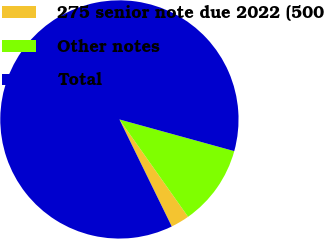Convert chart to OTSL. <chart><loc_0><loc_0><loc_500><loc_500><pie_chart><fcel>275 senior note due 2022 (500<fcel>Other notes<fcel>Total<nl><fcel>2.54%<fcel>10.94%<fcel>86.52%<nl></chart> 